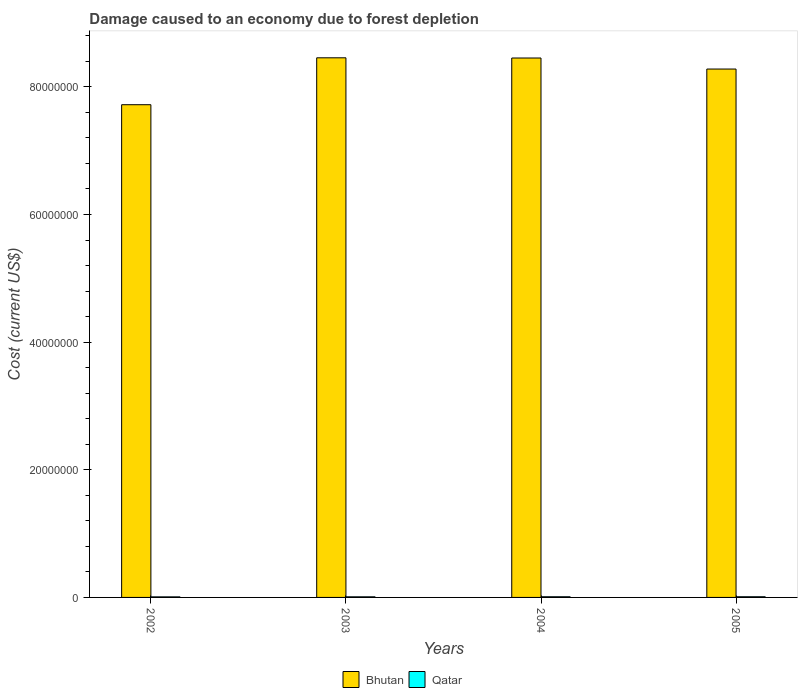How many different coloured bars are there?
Provide a short and direct response. 2. Are the number of bars per tick equal to the number of legend labels?
Make the answer very short. Yes. Are the number of bars on each tick of the X-axis equal?
Offer a very short reply. Yes. How many bars are there on the 3rd tick from the right?
Give a very brief answer. 2. What is the label of the 1st group of bars from the left?
Ensure brevity in your answer.  2002. In how many cases, is the number of bars for a given year not equal to the number of legend labels?
Your response must be concise. 0. What is the cost of damage caused due to forest depletion in Qatar in 2005?
Provide a succinct answer. 1.06e+05. Across all years, what is the maximum cost of damage caused due to forest depletion in Qatar?
Provide a succinct answer. 1.06e+05. Across all years, what is the minimum cost of damage caused due to forest depletion in Bhutan?
Ensure brevity in your answer.  7.72e+07. In which year was the cost of damage caused due to forest depletion in Bhutan maximum?
Give a very brief answer. 2003. In which year was the cost of damage caused due to forest depletion in Bhutan minimum?
Give a very brief answer. 2002. What is the total cost of damage caused due to forest depletion in Qatar in the graph?
Make the answer very short. 3.93e+05. What is the difference between the cost of damage caused due to forest depletion in Bhutan in 2004 and that in 2005?
Offer a very short reply. 1.73e+06. What is the difference between the cost of damage caused due to forest depletion in Qatar in 2003 and the cost of damage caused due to forest depletion in Bhutan in 2004?
Keep it short and to the point. -8.44e+07. What is the average cost of damage caused due to forest depletion in Bhutan per year?
Your answer should be very brief. 8.23e+07. In the year 2005, what is the difference between the cost of damage caused due to forest depletion in Qatar and cost of damage caused due to forest depletion in Bhutan?
Your response must be concise. -8.27e+07. What is the ratio of the cost of damage caused due to forest depletion in Qatar in 2002 to that in 2003?
Offer a terse response. 0.93. Is the cost of damage caused due to forest depletion in Qatar in 2003 less than that in 2004?
Your answer should be very brief. Yes. What is the difference between the highest and the second highest cost of damage caused due to forest depletion in Bhutan?
Keep it short and to the point. 3.20e+04. What is the difference between the highest and the lowest cost of damage caused due to forest depletion in Qatar?
Give a very brief answer. 1.85e+04. Is the sum of the cost of damage caused due to forest depletion in Bhutan in 2002 and 2005 greater than the maximum cost of damage caused due to forest depletion in Qatar across all years?
Make the answer very short. Yes. What does the 2nd bar from the left in 2004 represents?
Your answer should be very brief. Qatar. What does the 1st bar from the right in 2004 represents?
Your answer should be very brief. Qatar. How many bars are there?
Keep it short and to the point. 8. Are all the bars in the graph horizontal?
Make the answer very short. No. Are the values on the major ticks of Y-axis written in scientific E-notation?
Provide a short and direct response. No. Where does the legend appear in the graph?
Provide a short and direct response. Bottom center. How are the legend labels stacked?
Your response must be concise. Horizontal. What is the title of the graph?
Your response must be concise. Damage caused to an economy due to forest depletion. Does "Bolivia" appear as one of the legend labels in the graph?
Provide a short and direct response. No. What is the label or title of the X-axis?
Provide a short and direct response. Years. What is the label or title of the Y-axis?
Provide a succinct answer. Cost (current US$). What is the Cost (current US$) in Bhutan in 2002?
Keep it short and to the point. 7.72e+07. What is the Cost (current US$) of Qatar in 2002?
Your answer should be compact. 8.75e+04. What is the Cost (current US$) of Bhutan in 2003?
Keep it short and to the point. 8.46e+07. What is the Cost (current US$) of Qatar in 2003?
Give a very brief answer. 9.39e+04. What is the Cost (current US$) of Bhutan in 2004?
Provide a short and direct response. 8.45e+07. What is the Cost (current US$) of Qatar in 2004?
Provide a succinct answer. 1.05e+05. What is the Cost (current US$) in Bhutan in 2005?
Provide a short and direct response. 8.28e+07. What is the Cost (current US$) in Qatar in 2005?
Keep it short and to the point. 1.06e+05. Across all years, what is the maximum Cost (current US$) of Bhutan?
Ensure brevity in your answer.  8.46e+07. Across all years, what is the maximum Cost (current US$) in Qatar?
Your answer should be compact. 1.06e+05. Across all years, what is the minimum Cost (current US$) of Bhutan?
Provide a succinct answer. 7.72e+07. Across all years, what is the minimum Cost (current US$) of Qatar?
Make the answer very short. 8.75e+04. What is the total Cost (current US$) of Bhutan in the graph?
Give a very brief answer. 3.29e+08. What is the total Cost (current US$) in Qatar in the graph?
Keep it short and to the point. 3.93e+05. What is the difference between the Cost (current US$) of Bhutan in 2002 and that in 2003?
Make the answer very short. -7.35e+06. What is the difference between the Cost (current US$) of Qatar in 2002 and that in 2003?
Provide a short and direct response. -6343.9. What is the difference between the Cost (current US$) of Bhutan in 2002 and that in 2004?
Offer a very short reply. -7.32e+06. What is the difference between the Cost (current US$) of Qatar in 2002 and that in 2004?
Offer a very short reply. -1.79e+04. What is the difference between the Cost (current US$) in Bhutan in 2002 and that in 2005?
Your response must be concise. -5.59e+06. What is the difference between the Cost (current US$) of Qatar in 2002 and that in 2005?
Keep it short and to the point. -1.85e+04. What is the difference between the Cost (current US$) of Bhutan in 2003 and that in 2004?
Offer a very short reply. 3.20e+04. What is the difference between the Cost (current US$) in Qatar in 2003 and that in 2004?
Offer a very short reply. -1.16e+04. What is the difference between the Cost (current US$) in Bhutan in 2003 and that in 2005?
Provide a short and direct response. 1.76e+06. What is the difference between the Cost (current US$) in Qatar in 2003 and that in 2005?
Provide a short and direct response. -1.22e+04. What is the difference between the Cost (current US$) in Bhutan in 2004 and that in 2005?
Offer a very short reply. 1.73e+06. What is the difference between the Cost (current US$) of Qatar in 2004 and that in 2005?
Offer a very short reply. -583.23. What is the difference between the Cost (current US$) in Bhutan in 2002 and the Cost (current US$) in Qatar in 2003?
Make the answer very short. 7.71e+07. What is the difference between the Cost (current US$) in Bhutan in 2002 and the Cost (current US$) in Qatar in 2004?
Your answer should be compact. 7.71e+07. What is the difference between the Cost (current US$) of Bhutan in 2002 and the Cost (current US$) of Qatar in 2005?
Ensure brevity in your answer.  7.71e+07. What is the difference between the Cost (current US$) of Bhutan in 2003 and the Cost (current US$) of Qatar in 2004?
Your answer should be very brief. 8.45e+07. What is the difference between the Cost (current US$) of Bhutan in 2003 and the Cost (current US$) of Qatar in 2005?
Make the answer very short. 8.44e+07. What is the difference between the Cost (current US$) in Bhutan in 2004 and the Cost (current US$) in Qatar in 2005?
Make the answer very short. 8.44e+07. What is the average Cost (current US$) of Bhutan per year?
Offer a very short reply. 8.23e+07. What is the average Cost (current US$) in Qatar per year?
Give a very brief answer. 9.82e+04. In the year 2002, what is the difference between the Cost (current US$) in Bhutan and Cost (current US$) in Qatar?
Your answer should be very brief. 7.71e+07. In the year 2003, what is the difference between the Cost (current US$) in Bhutan and Cost (current US$) in Qatar?
Ensure brevity in your answer.  8.45e+07. In the year 2004, what is the difference between the Cost (current US$) of Bhutan and Cost (current US$) of Qatar?
Offer a terse response. 8.44e+07. In the year 2005, what is the difference between the Cost (current US$) of Bhutan and Cost (current US$) of Qatar?
Make the answer very short. 8.27e+07. What is the ratio of the Cost (current US$) of Bhutan in 2002 to that in 2003?
Your answer should be very brief. 0.91. What is the ratio of the Cost (current US$) of Qatar in 2002 to that in 2003?
Provide a succinct answer. 0.93. What is the ratio of the Cost (current US$) in Bhutan in 2002 to that in 2004?
Keep it short and to the point. 0.91. What is the ratio of the Cost (current US$) of Qatar in 2002 to that in 2004?
Offer a very short reply. 0.83. What is the ratio of the Cost (current US$) in Bhutan in 2002 to that in 2005?
Your response must be concise. 0.93. What is the ratio of the Cost (current US$) of Qatar in 2002 to that in 2005?
Give a very brief answer. 0.83. What is the ratio of the Cost (current US$) in Bhutan in 2003 to that in 2004?
Your response must be concise. 1. What is the ratio of the Cost (current US$) of Qatar in 2003 to that in 2004?
Provide a short and direct response. 0.89. What is the ratio of the Cost (current US$) of Bhutan in 2003 to that in 2005?
Provide a succinct answer. 1.02. What is the ratio of the Cost (current US$) of Qatar in 2003 to that in 2005?
Ensure brevity in your answer.  0.89. What is the ratio of the Cost (current US$) of Bhutan in 2004 to that in 2005?
Your answer should be very brief. 1.02. What is the ratio of the Cost (current US$) of Qatar in 2004 to that in 2005?
Offer a very short reply. 0.99. What is the difference between the highest and the second highest Cost (current US$) in Bhutan?
Provide a succinct answer. 3.20e+04. What is the difference between the highest and the second highest Cost (current US$) in Qatar?
Give a very brief answer. 583.23. What is the difference between the highest and the lowest Cost (current US$) in Bhutan?
Provide a succinct answer. 7.35e+06. What is the difference between the highest and the lowest Cost (current US$) of Qatar?
Ensure brevity in your answer.  1.85e+04. 